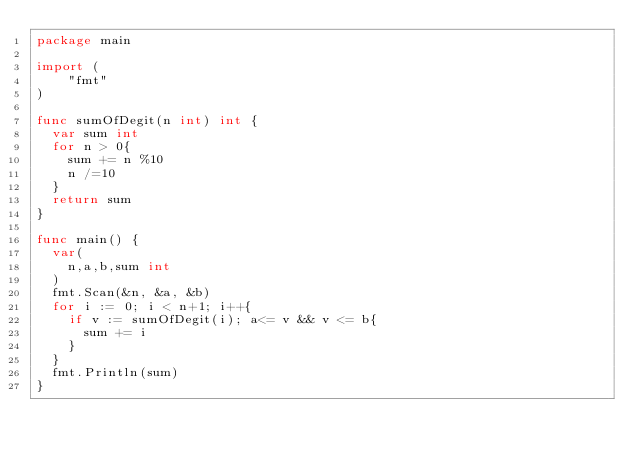<code> <loc_0><loc_0><loc_500><loc_500><_Go_>package main

import (
    "fmt"
)

func sumOfDegit(n int) int {
	var sum int
  for n > 0{
    sum += n %10
    n /=10
  }
  return sum
}

func main() {
  var(
    n,a,b,sum int
  )
  fmt.Scan(&n, &a, &b)
  for i := 0; i < n+1; i++{
    if v := sumOfDegit(i); a<= v && v <= b{
      sum += i
    }    
  }
  fmt.Println(sum)
}</code> 